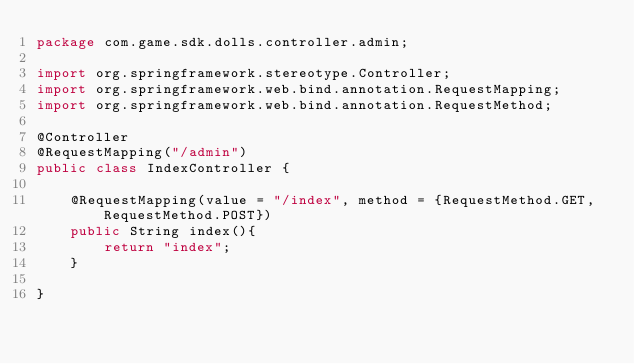<code> <loc_0><loc_0><loc_500><loc_500><_Java_>package com.game.sdk.dolls.controller.admin;

import org.springframework.stereotype.Controller;
import org.springframework.web.bind.annotation.RequestMapping;
import org.springframework.web.bind.annotation.RequestMethod;

@Controller
@RequestMapping("/admin")
public class IndexController {

    @RequestMapping(value = "/index", method = {RequestMethod.GET, RequestMethod.POST})
    public String index(){
        return "index";
    }

}
</code> 